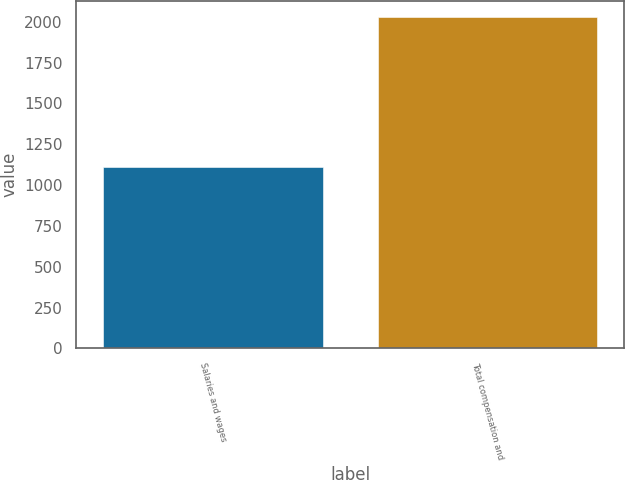<chart> <loc_0><loc_0><loc_500><loc_500><bar_chart><fcel>Salaries and wages<fcel>Total compensation and<nl><fcel>1110<fcel>2027<nl></chart> 